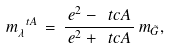<formula> <loc_0><loc_0><loc_500><loc_500>m ^ { \ t A } _ { \lambda } \, = \, \frac { \, e ^ { 2 } - \ t c A \, } { \, e ^ { 2 } + \ t c A \, } \, m _ { \tilde { G } } ,</formula> 